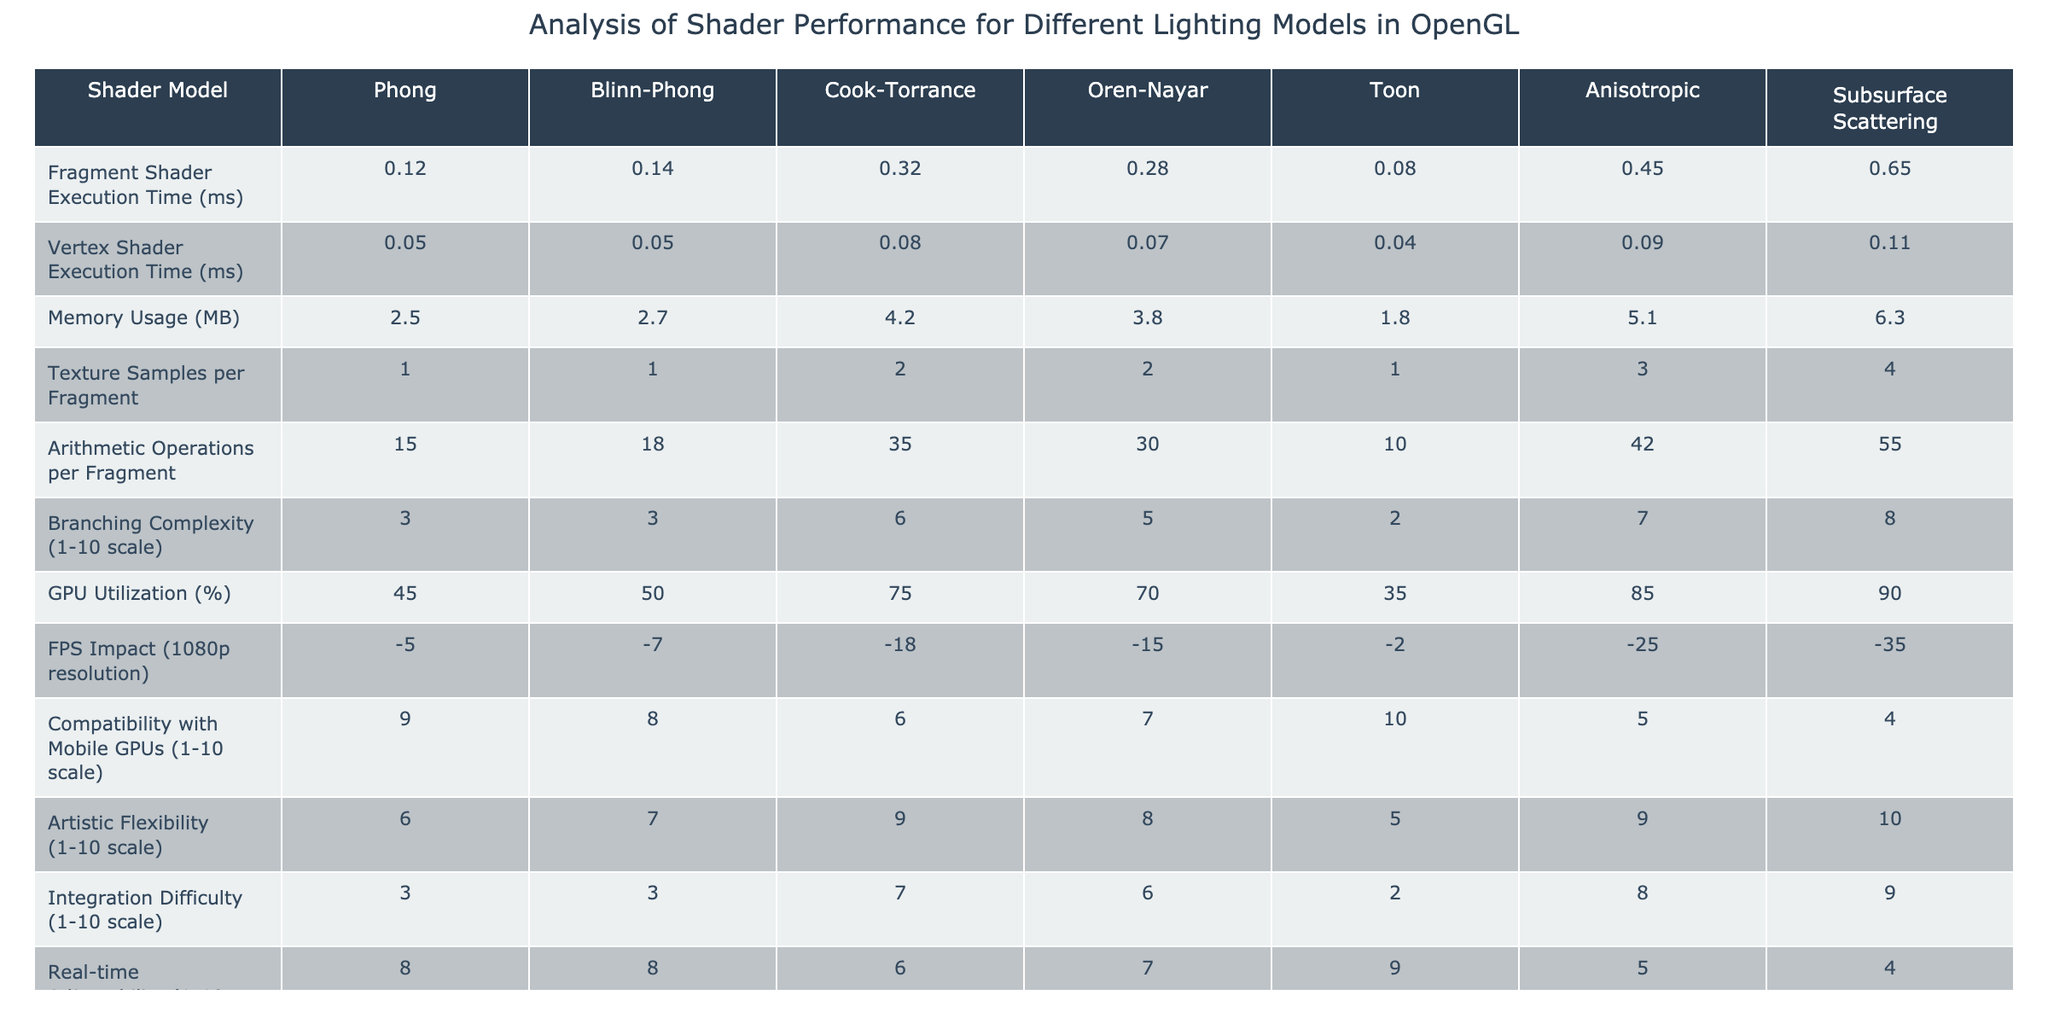What is the fragment shader execution time for the Cook-Torrance model? The table shows that the fragment shader execution time for the Cook-Torrance model is 0.32 ms.
Answer: 0.32 ms Which shader model has the highest memory usage? The table lists the memory usage for each shader model, and the Cook-Torrance model has the highest value at 4.2 MB.
Answer: Cook-Torrance What is the FPS impact of using the Toon shader model? The Toon shader model has an FPS impact of -2, as listed in the table.
Answer: -2 Which shader model requires the most arithmetic operations per fragment? The table indicates that the Anisotropic model requires the most arithmetic operations per fragment at 42.
Answer: Anisotropic What is the average GPU utilization of the Phong and Blinn-Phong models? The GPU utilization for the Phong model is 45% and for the Blinn-Phong model is 50%. The average is (45 + 50) / 2 = 47.5%.
Answer: 47.5% Is the Subsurface Scattering model compatible with mobile GPUs rated above 5? The compatibility rating for the Subsurface Scattering model is 4, which is not above 5.
Answer: No How does the real-time adjustability of the Phong model compare to the Toon model? The real-time adjustability of the Phong model is rated at 8, while the Toon model is rated at 9. Phong is less adjustable than Toon.
Answer: Phong is less adjustable What is the difference in fragment shader execution time between the Phong and Oren-Nayar models? The fragment shader execution time for the Phong model is 0.12 ms and for the Oren-Nayar model is 0.28 ms. The difference is 0.28 - 0.12 = 0.16 ms.
Answer: 0.16 ms Which shader model has the highest branching complexity, and what is that value? The table shows that the shader model with the highest branching complexity is Subsurface Scattering, with a value of 8.
Answer: Subsurface Scattering, 8 What is the total memory usage for all shader models? Summing the memory usage values, we get 2.5 + 2.7 + 4.2 + 3.8 + 1.8 + 5.1 + 6.3 = 26.4 MB.
Answer: 26.4 MB 